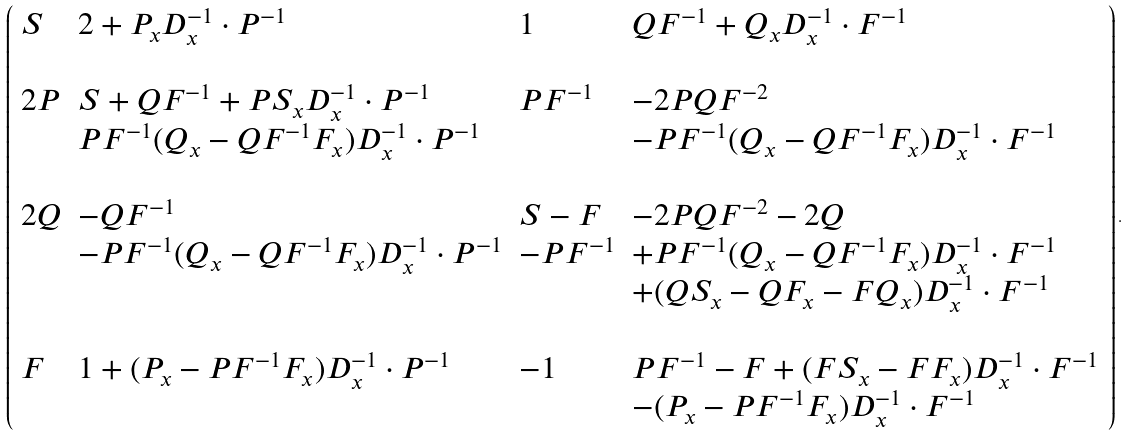Convert formula to latex. <formula><loc_0><loc_0><loc_500><loc_500>\left ( \begin{array} { l l l l } S & 2 + P _ { x } D _ { x } ^ { - 1 } \cdot P ^ { - 1 } & 1 & Q F ^ { - 1 } + Q _ { x } D _ { x } ^ { - 1 } \cdot F ^ { - 1 } \\ & & & \\ 2 P & S + Q F ^ { - 1 } + P S _ { x } D _ { x } ^ { - 1 } \cdot P ^ { - 1 } & P F ^ { - 1 } & - 2 P Q F ^ { - 2 } \\ & P F ^ { - 1 } ( Q _ { x } - Q F ^ { - 1 } F _ { x } ) D _ { x } ^ { - 1 } \cdot P ^ { - 1 } & & - P F ^ { - 1 } ( Q _ { x } - Q F ^ { - 1 } F _ { x } ) D _ { x } ^ { - 1 } \cdot F ^ { - 1 } \\ & & & \\ 2 Q & - Q F ^ { - 1 } & S - F & - 2 P Q F ^ { - 2 } - 2 Q \\ & - P F ^ { - 1 } ( Q _ { x } - Q F ^ { - 1 } F _ { x } ) D _ { x } ^ { - 1 } \cdot P ^ { - 1 } & - P F ^ { - 1 } & + P F ^ { - 1 } ( Q _ { x } - Q F ^ { - 1 } F _ { x } ) D _ { x } ^ { - 1 } \cdot F ^ { - 1 } \\ & & & + ( Q S _ { x } - Q F _ { x } - F Q _ { x } ) D _ { x } ^ { - 1 } \cdot F ^ { - 1 } \\ & & & \\ F & 1 + ( P _ { x } - P F ^ { - 1 } F _ { x } ) D _ { x } ^ { - 1 } \cdot P ^ { - 1 } & - 1 & P F ^ { - 1 } - F + ( F S _ { x } - F F _ { x } ) D _ { x } ^ { - 1 } \cdot F ^ { - 1 } \\ & & & - ( P _ { x } - P F ^ { - 1 } F _ { x } ) D _ { x } ^ { - 1 } \cdot F ^ { - 1 } \\ \end{array} \right ) .</formula> 